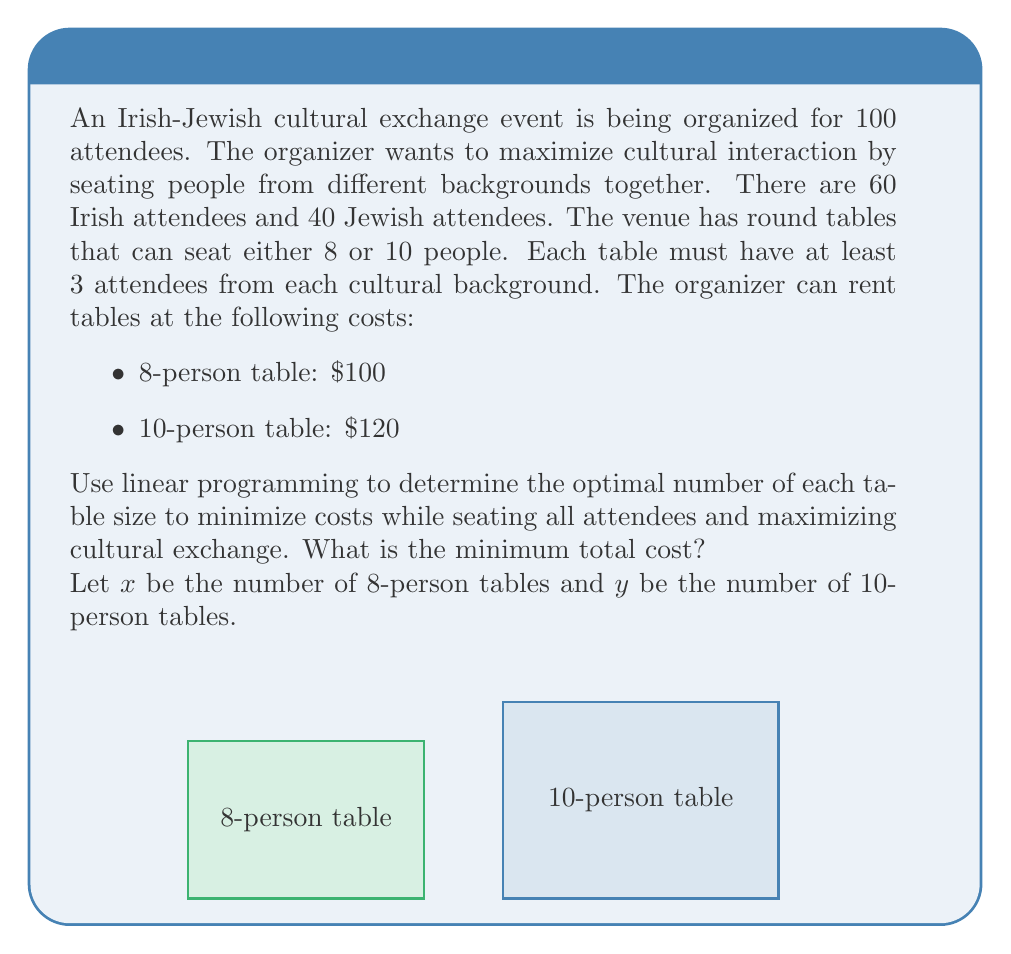Teach me how to tackle this problem. Let's approach this step-by-step:

1) Objective function: Minimize total cost
   $$ \text{Minimize } Z = 100x + 120y $$

2) Constraints:
   a) Total seating capacity:
      $$ 8x + 10y \geq 100 $$
   
   b) Irish attendees (at least 3 per table):
      $$ 3x + 3y \leq 60 $$
   
   c) Jewish attendees (at least 3 per table):
      $$ 3x + 3y \leq 40 $$
   
   d) Non-negativity:
      $$ x, y \geq 0 $$

3) Simplify constraints:
   From (b) and (c), we can see that (c) is more restrictive:
   $$ 3x + 3y \leq 40 $$
   $$ x + y \leq 13.33 $$

4) Solve graphically or using the simplex method. The feasible integer solutions are:
   $$(x,y) = (8,5), (6,7), (4,9), (2,11), (0,13)$$

5) Evaluate the objective function for each:
   $$(8,5): 100(8) + 120(5) = 1400$$
   $$(6,7): 100(6) + 120(7) = 1440$$
   $$(4,9): 100(4) + 120(9) = 1480$$
   $$(2,11): 100(2) + 120(11) = 1520$$
   $$(0,13): 100(0) + 120(13) = 1560$$

6) The minimum cost is $1400, achieved with 8 eight-person tables and 5 ten-person tables.
Answer: $1400 